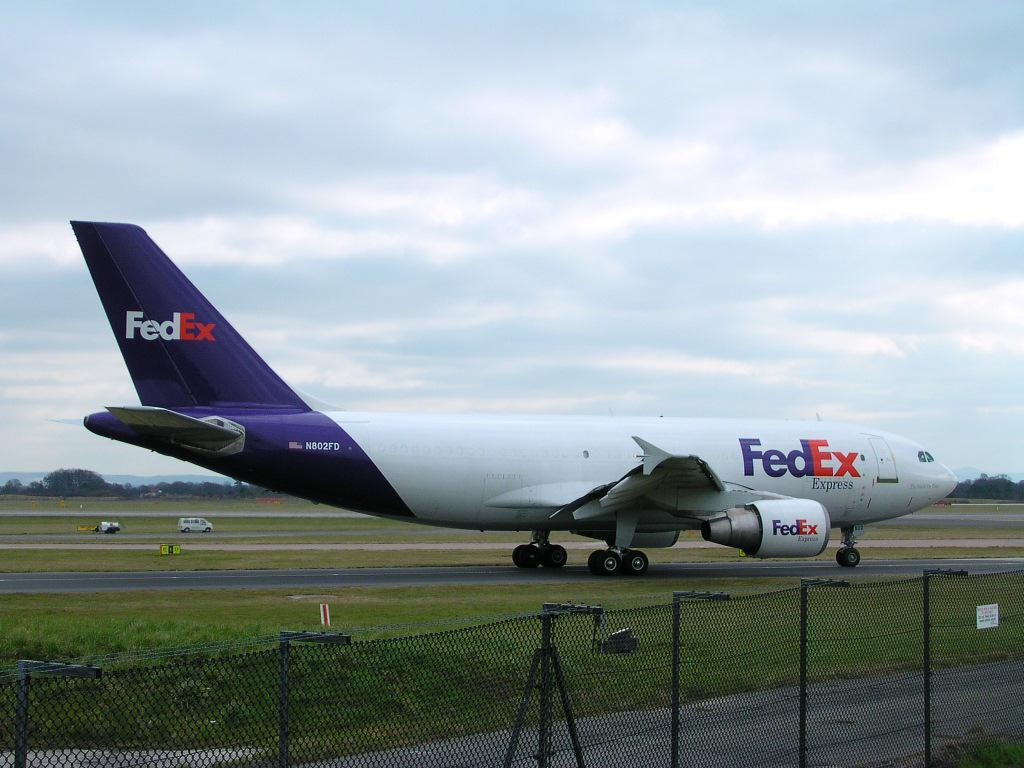<image>
Present a compact description of the photo's key features. Blue and white airplane from FedEx with an american flag and N802FD 